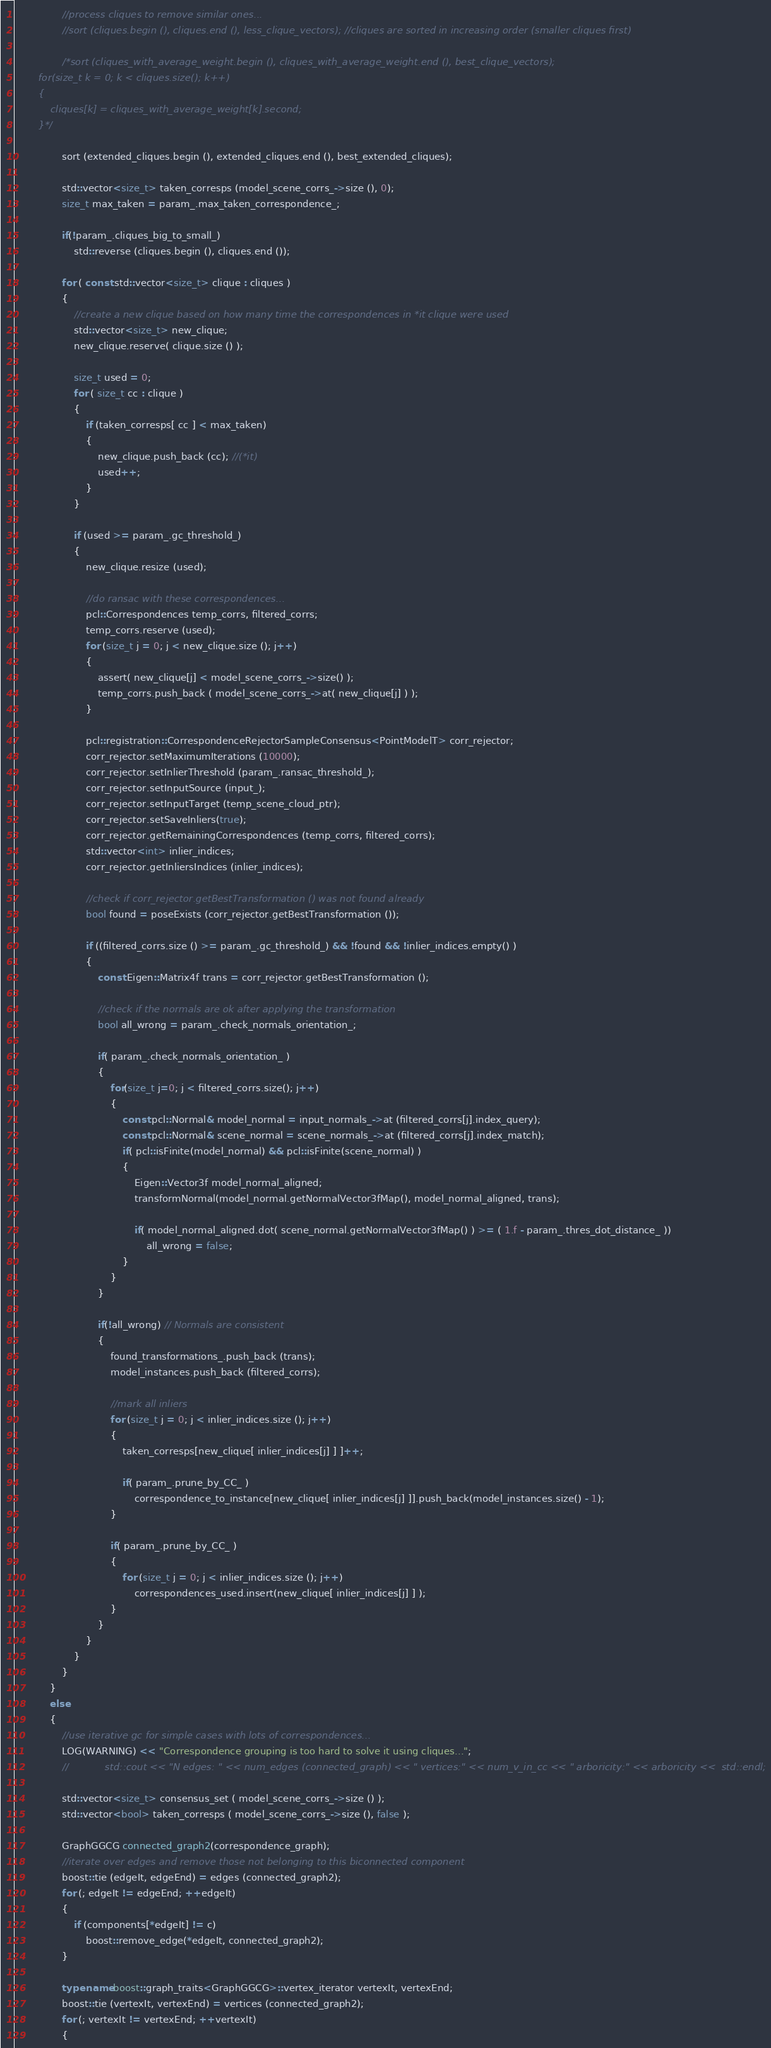Convert code to text. <code><loc_0><loc_0><loc_500><loc_500><_C++_>                //process cliques to remove similar ones...
                //sort (cliques.begin (), cliques.end (), less_clique_vectors); //cliques are sorted in increasing order (smaller cliques first)

                /*sort (cliques_with_average_weight.begin (), cliques_with_average_weight.end (), best_clique_vectors);
        for(size_t k = 0; k < cliques.size(); k++)
        {
            cliques[k] = cliques_with_average_weight[k].second;
        }*/

                sort (extended_cliques.begin (), extended_cliques.end (), best_extended_cliques);

                std::vector<size_t> taken_corresps (model_scene_corrs_->size (), 0);
                size_t max_taken = param_.max_taken_correspondence_;

                if(!param_.cliques_big_to_small_)
                    std::reverse (cliques.begin (), cliques.end ());

                for ( const std::vector<size_t> clique : cliques )
                {
                    //create a new clique based on how many time the correspondences in *it clique were used
                    std::vector<size_t> new_clique;
                    new_clique.reserve( clique.size () );

                    size_t used = 0;
                    for ( size_t cc : clique )
                    {
                        if (taken_corresps[ cc ] < max_taken)
                        {
                            new_clique.push_back (cc); //(*it)
                            used++;
                        }
                    }

                    if (used >= param_.gc_threshold_)
                    {
                        new_clique.resize (used);

                        //do ransac with these correspondences...
                        pcl::Correspondences temp_corrs, filtered_corrs;
                        temp_corrs.reserve (used);
                        for (size_t j = 0; j < new_clique.size (); j++)
                        {
                            assert( new_clique[j] < model_scene_corrs_->size() );
                            temp_corrs.push_back ( model_scene_corrs_->at( new_clique[j] ) );
                        }

                        pcl::registration::CorrespondenceRejectorSampleConsensus<PointModelT> corr_rejector;
                        corr_rejector.setMaximumIterations (10000);
                        corr_rejector.setInlierThreshold (param_.ransac_threshold_);
                        corr_rejector.setInputSource (input_);
                        corr_rejector.setInputTarget (temp_scene_cloud_ptr);
                        corr_rejector.setSaveInliers(true);
                        corr_rejector.getRemainingCorrespondences (temp_corrs, filtered_corrs);
                        std::vector<int> inlier_indices;
                        corr_rejector.getInliersIndices (inlier_indices);

                        //check if corr_rejector.getBestTransformation () was not found already
                        bool found = poseExists (corr_rejector.getBestTransformation ());

                        if ((filtered_corrs.size () >= param_.gc_threshold_) && !found && !inlier_indices.empty() )
                        {
                            const Eigen::Matrix4f trans = corr_rejector.getBestTransformation ();

                            //check if the normals are ok after applying the transformation
                            bool all_wrong = param_.check_normals_orientation_;

                            if( param_.check_normals_orientation_ )
                            {
                                for(size_t j=0; j < filtered_corrs.size(); j++)
                                {
                                    const pcl::Normal& model_normal = input_normals_->at (filtered_corrs[j].index_query);
                                    const pcl::Normal& scene_normal = scene_normals_->at (filtered_corrs[j].index_match);
                                    if( pcl::isFinite(model_normal) && pcl::isFinite(scene_normal) )
                                    {
                                        Eigen::Vector3f model_normal_aligned;
                                        transformNormal(model_normal.getNormalVector3fMap(), model_normal_aligned, trans);

                                        if( model_normal_aligned.dot( scene_normal.getNormalVector3fMap() ) >= ( 1.f - param_.thres_dot_distance_ ))
                                            all_wrong = false;
                                    }
                                }
                            }

                            if(!all_wrong) // Normals are consistent
                            {
                                found_transformations_.push_back (trans);
                                model_instances.push_back (filtered_corrs);

                                //mark all inliers
                                for (size_t j = 0; j < inlier_indices.size (); j++)
                                {
                                    taken_corresps[new_clique[ inlier_indices[j] ] ]++;

                                    if( param_.prune_by_CC_ )
                                        correspondence_to_instance[new_clique[ inlier_indices[j] ]].push_back(model_instances.size() - 1);
                                }

                                if( param_.prune_by_CC_ )
                                {
                                    for (size_t j = 0; j < inlier_indices.size (); j++)
                                        correspondences_used.insert(new_clique[ inlier_indices[j] ] );
                                }
                            }
                        }
                    }
                }
            }
            else
            {
                //use iterative gc for simple cases with lots of correspondences...
                LOG(WARNING) << "Correspondence grouping is too hard to solve it using cliques...";
                //            std::cout << "N edges: " << num_edges (connected_graph) << " vertices:" << num_v_in_cc << " arboricity:" << arboricity <<  std::endl;

                std::vector<size_t> consensus_set ( model_scene_corrs_->size () );
                std::vector<bool> taken_corresps ( model_scene_corrs_->size (), false );

                GraphGGCG connected_graph2(correspondence_graph);
                //iterate over edges and remove those not belonging to this biconnected component
                boost::tie (edgeIt, edgeEnd) = edges (connected_graph2);
                for (; edgeIt != edgeEnd; ++edgeIt)
                {
                    if (components[*edgeIt] != c)
                        boost::remove_edge(*edgeIt, connected_graph2);
                }

                typename boost::graph_traits<GraphGGCG>::vertex_iterator vertexIt, vertexEnd;
                boost::tie (vertexIt, vertexEnd) = vertices (connected_graph2);
                for (; vertexIt != vertexEnd; ++vertexIt)
                {</code> 